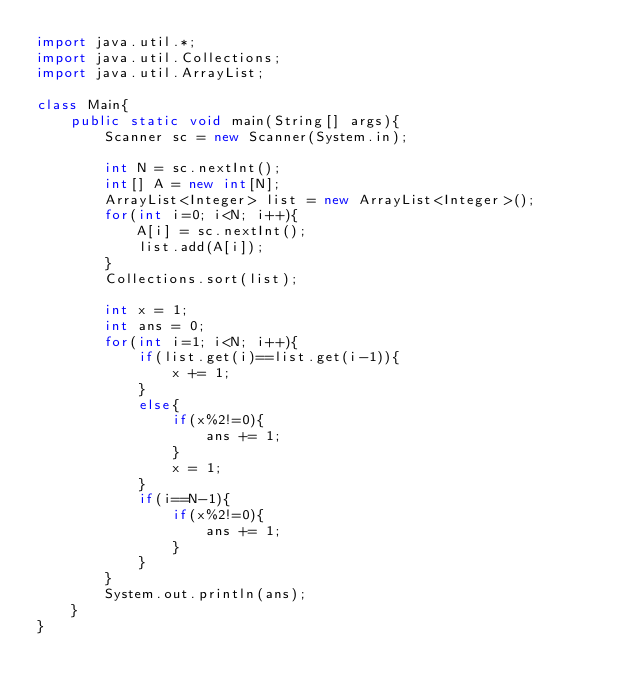Convert code to text. <code><loc_0><loc_0><loc_500><loc_500><_Java_>import java.util.*;
import java.util.Collections;
import java.util.ArrayList;

class Main{
    public static void main(String[] args){
        Scanner sc = new Scanner(System.in);

        int N = sc.nextInt();
        int[] A = new int[N];
        ArrayList<Integer> list = new ArrayList<Integer>();
        for(int i=0; i<N; i++){
            A[i] = sc.nextInt();
            list.add(A[i]);
        }
        Collections.sort(list);

        int x = 1;
        int ans = 0;
        for(int i=1; i<N; i++){
            if(list.get(i)==list.get(i-1)){
                x += 1;
            }
            else{
                if(x%2!=0){
                    ans += 1;
                }
                x = 1;
            }
            if(i==N-1){
                if(x%2!=0){
                    ans += 1;
                }
            }
        }
        System.out.println(ans);
    }
}</code> 